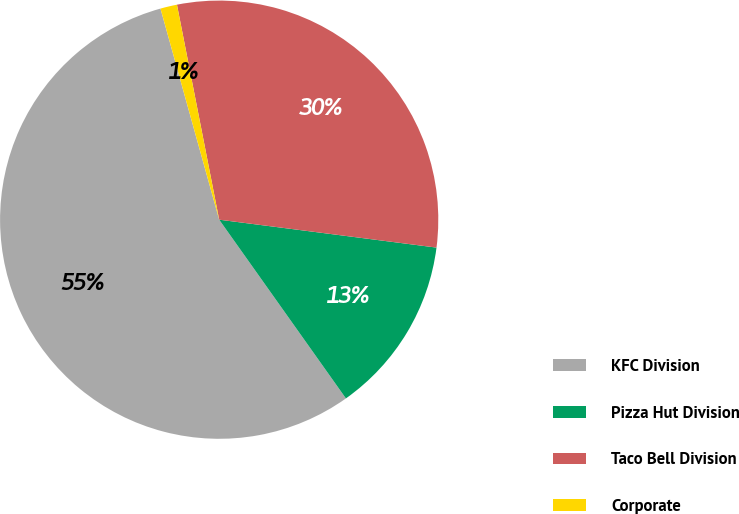<chart> <loc_0><loc_0><loc_500><loc_500><pie_chart><fcel>KFC Division<fcel>Pizza Hut Division<fcel>Taco Bell Division<fcel>Corporate<nl><fcel>55.5%<fcel>13.15%<fcel>30.12%<fcel>1.23%<nl></chart> 